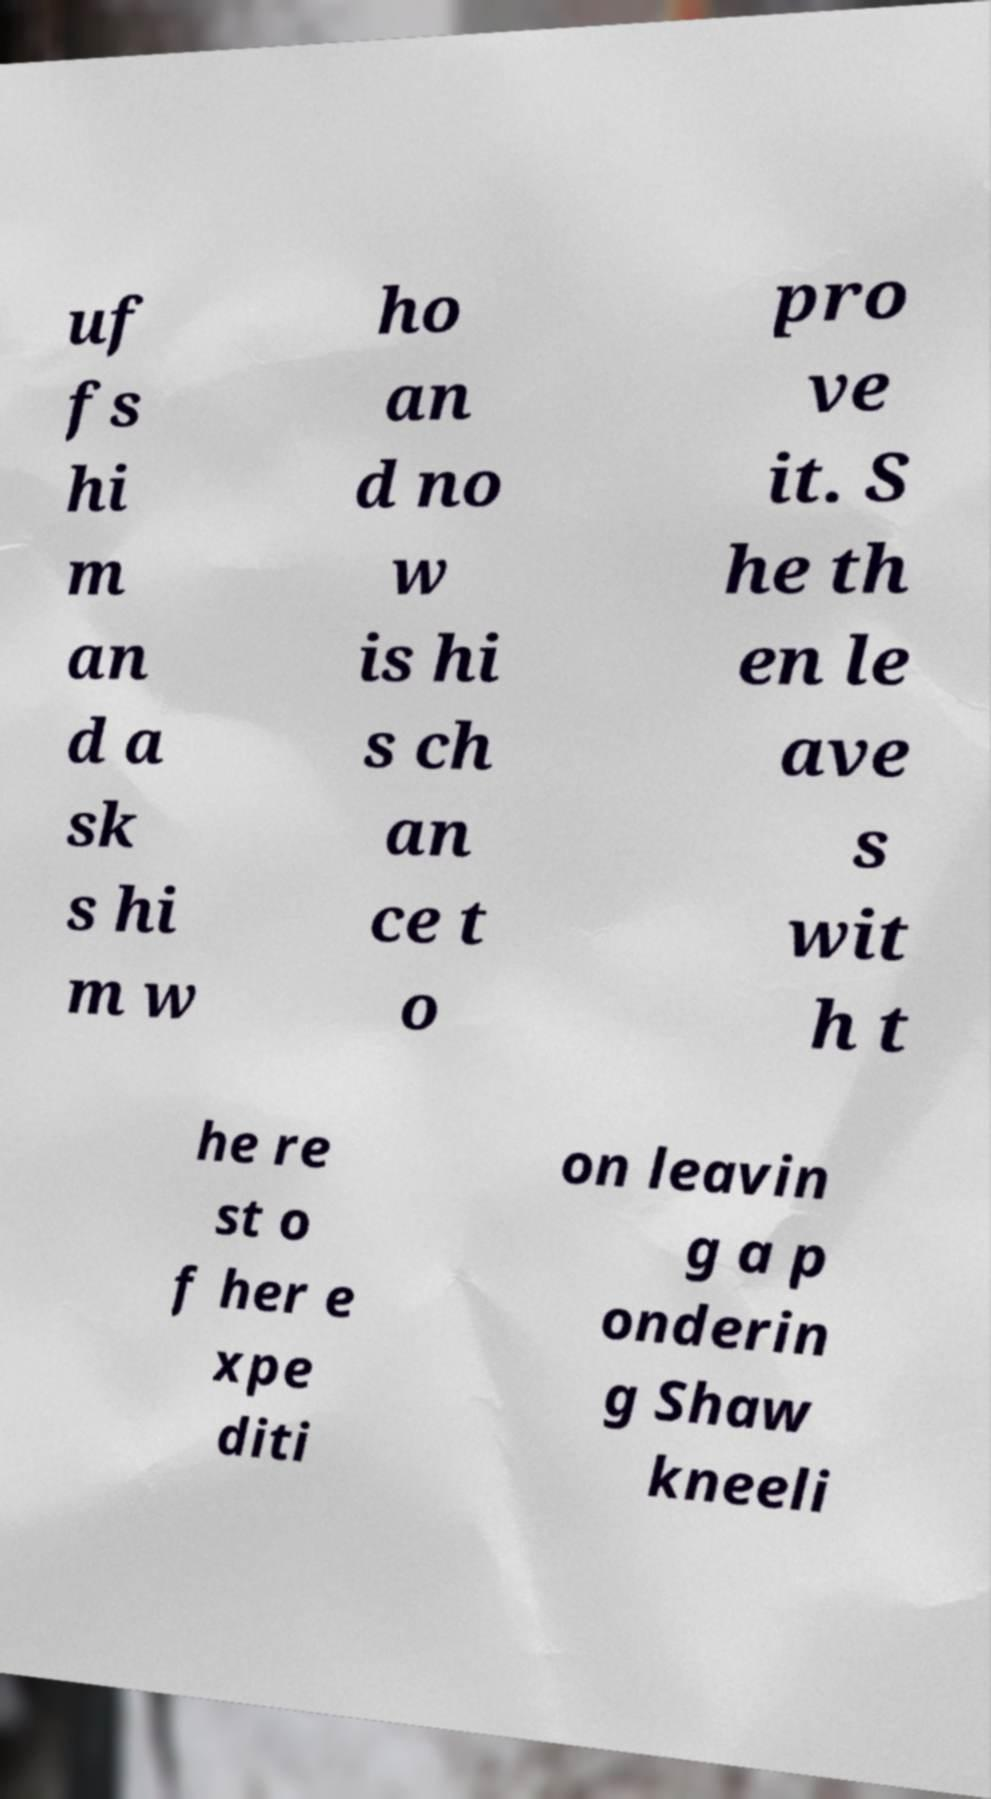Please identify and transcribe the text found in this image. uf fs hi m an d a sk s hi m w ho an d no w is hi s ch an ce t o pro ve it. S he th en le ave s wit h t he re st o f her e xpe diti on leavin g a p onderin g Shaw kneeli 